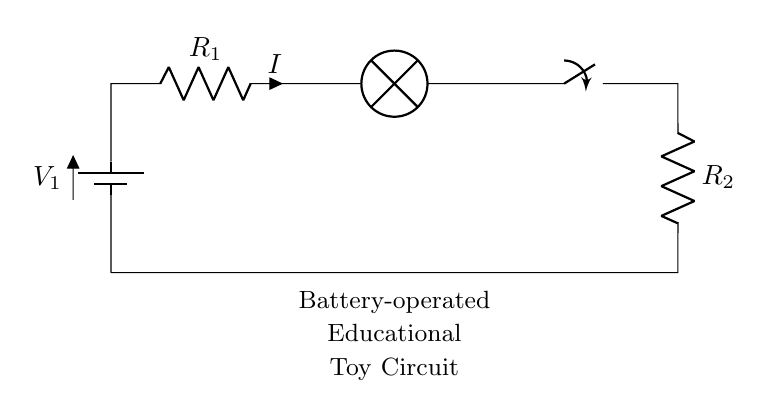What is the main power source of the circuit? The main power source in this circuit is the battery, indicated by the symbol labeled V1. It serves as the source of electrical energy for the entire circuit.
Answer: battery What does the resistor R1 represent? Resistor R1 is indicated in the circuit as a component labeled R1. Resistors limit the current flowing through the circuit, so R1 is there to control the current for the lamp.
Answer: current limitation What components are present in the circuit? The components present in the circuit include a battery, two resistors (R1 and R2), a lamp, and a switch. Each plays a specific role in ensuring the circuit operates correctly.
Answer: battery, resistors, lamp, switch What happens when the switch is open? When the switch is open, it interrupts the flow of current through the circuit, preventing the lamp from lighting up. The open switch creates a break in the circuit path.
Answer: lamp off How does current flow in a series circuit? In a series circuit, current flows through each component sequentially. The same current passes through each component without branching, which is characteristic of series circuits.
Answer: sequentially through all components What is the role of resistor R2 in this circuit? Resistor R2, like R1, also controls the amount of current flowing in the circuit. Its position after the switch indicates it provides additional resistance and ensures the lamp operates safely under the circuit's voltage.
Answer: additional resistance What would happen if the battery voltage is increased? If the battery voltage is increased, the current through the circuit will also increase according to Ohm's Law. This could result in brighter light from the lamp or even potentially damage the components if the voltage exceeds their ratings.
Answer: increased current 